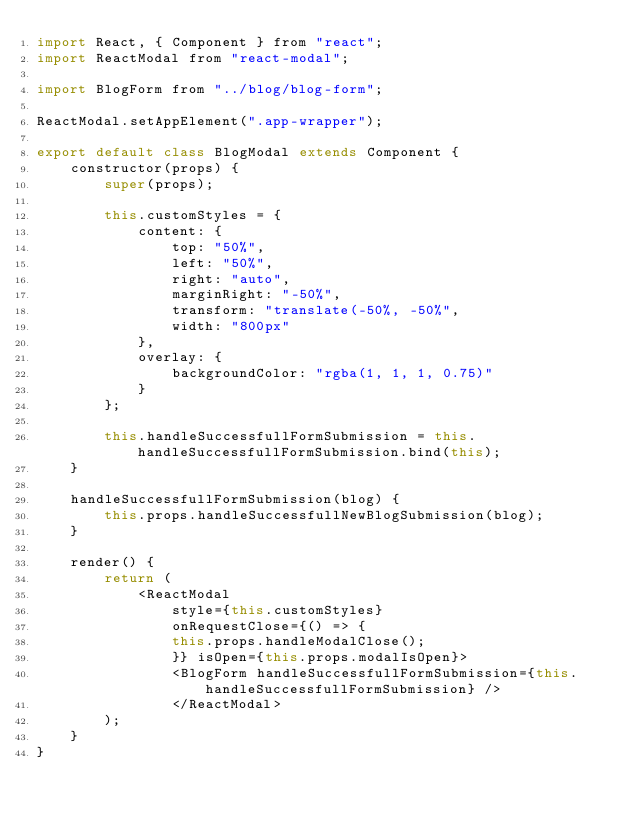<code> <loc_0><loc_0><loc_500><loc_500><_JavaScript_>import React, { Component } from "react";
import ReactModal from "react-modal";

import BlogForm from "../blog/blog-form";

ReactModal.setAppElement(".app-wrapper");

export default class BlogModal extends Component {
    constructor(props) {
        super(props);

        this.customStyles = {
            content: {
                top: "50%",
                left: "50%",
                right: "auto",
                marginRight: "-50%",
                transform: "translate(-50%, -50%",
                width: "800px"
            },
            overlay: {
                backgroundColor: "rgba(1, 1, 1, 0.75)"
            }
        };
        
        this.handleSuccessfullFormSubmission = this.handleSuccessfullFormSubmission.bind(this);
    }

    handleSuccessfullFormSubmission(blog) {
        this.props.handleSuccessfullNewBlogSubmission(blog);
    }

    render() {
        return (
            <ReactModal
                style={this.customStyles}
                onRequestClose={() => {
                this.props.handleModalClose();
                }} isOpen={this.props.modalIsOpen}>
                <BlogForm handleSuccessfullFormSubmission={this.handleSuccessfullFormSubmission} />
                </ReactModal>
        );
    }
}</code> 